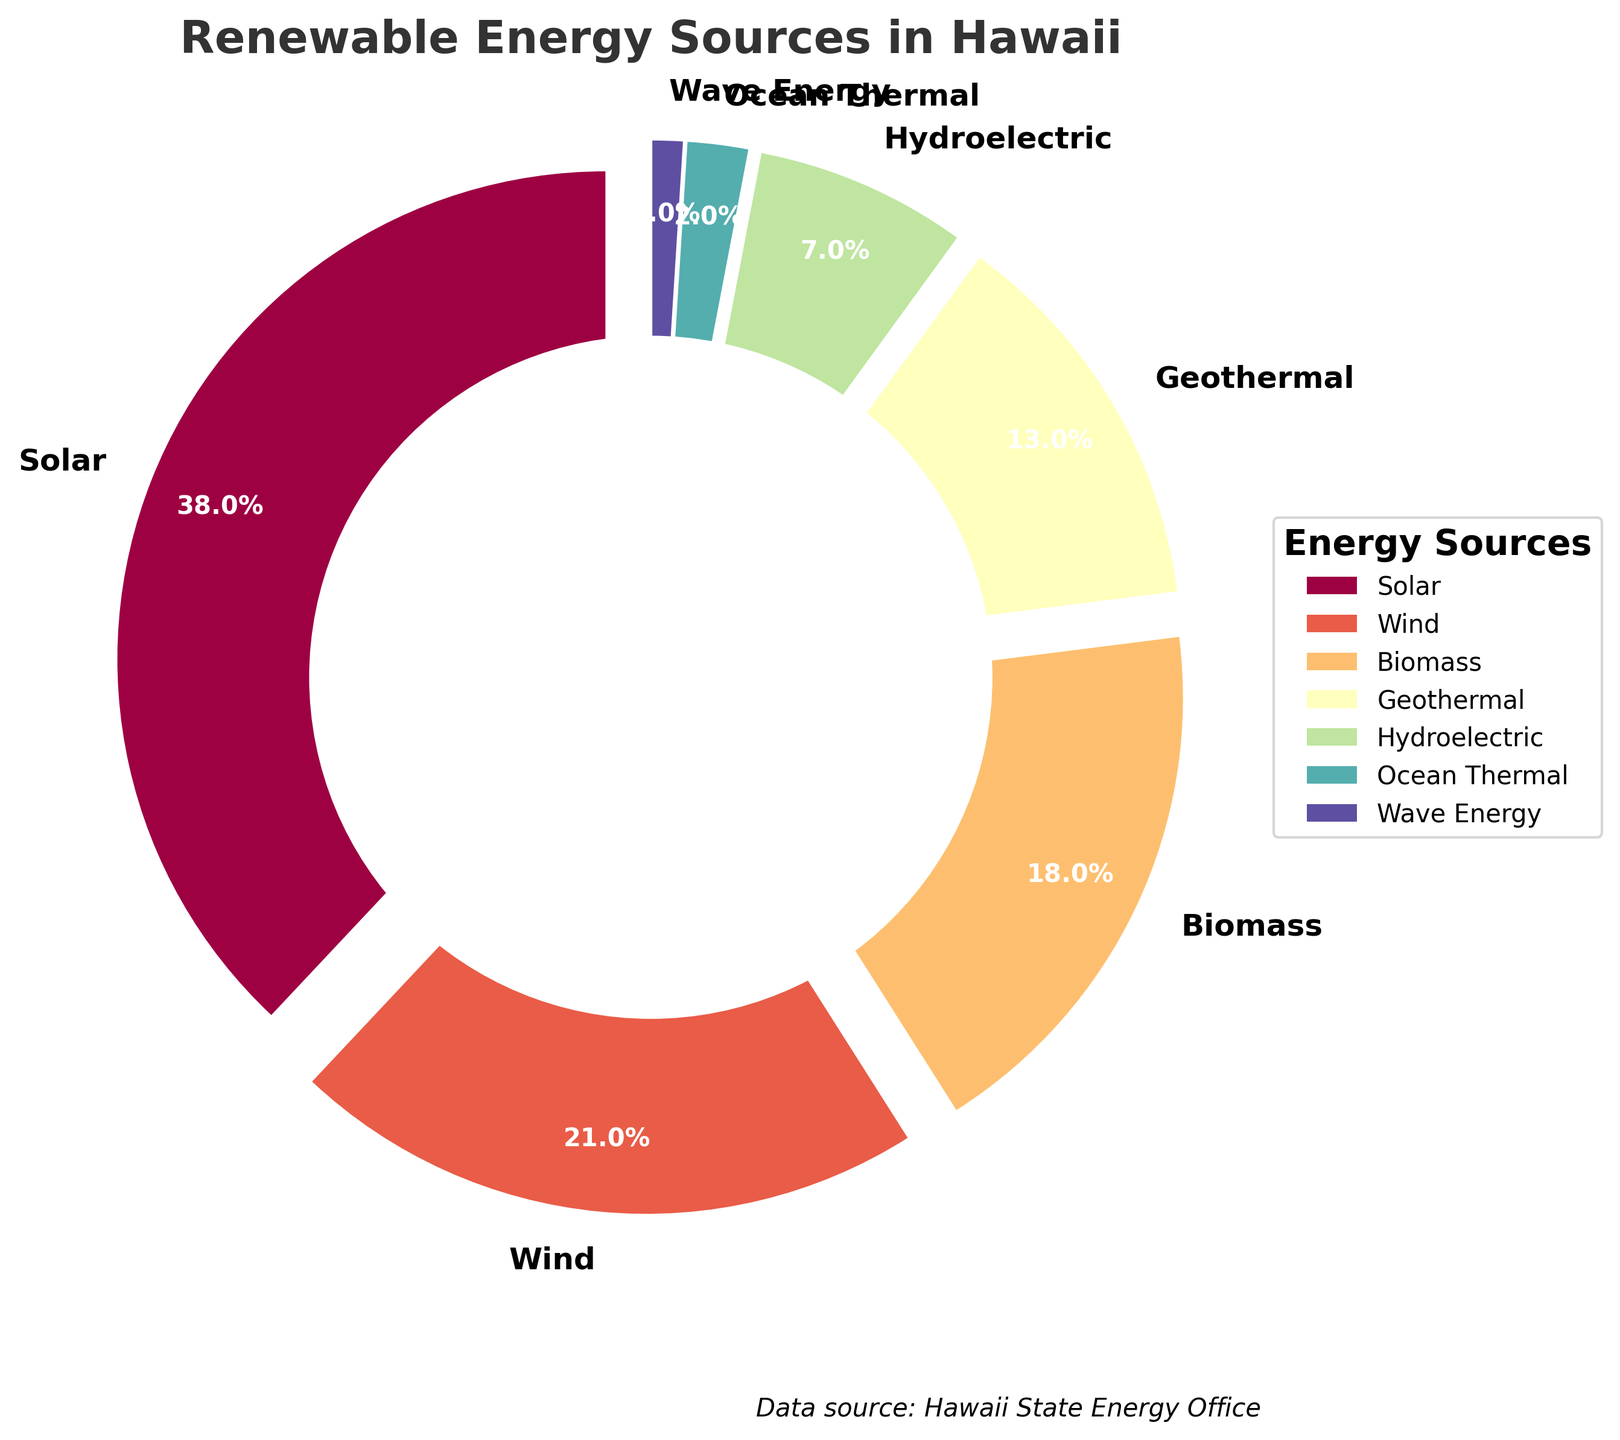What is the most common renewable energy source in Hawaii? The slice labeled with the highest percentage corresponds to the most common energy source. Here, Solar has the largest percentage of 38%.
Answer: Solar Which two sources combined represent over half of Hawaii's renewable energy? By adding the percentages of Solar and Wind (38% + 21%), we get 59%, which is more than half (50%).
Answer: Solar and Wind What is the percentage difference between Biomass and Geothermal energy sources? Subtract the percentage of Geothermal (13%) from the percentage of Biomass (18%) to find the difference. 18% - 13% = 5%.
Answer: 5% Which renewable energy source contributes the least, and what is its percentage? The smallest visible slice on the pie chart, with the lowest percentage, corresponds to Wave Energy. Its percentage is 1%.
Answer: Wave Energy, 1% Is the combined percentage of Hydroelectric and Ocean Thermal energy sources greater or less than that of Wind energy? Adding the percentages of Hydroelectric (7%) and Ocean Thermal (2%) gives us 9%. Since Wind accounts for 21%, 9% is less than 21%.
Answer: Less What is the average contribution of the three least common renewable energy sources? Adding the percentages of Ocean Thermal (2%), Wave Energy (1%), and Hydroelectric (7%) gives us 10%. The average is 10% divided by 3, which is approximately 3.33%.
Answer: ~3.33% How much more popular is Solar energy compared to Geothermal energy? Subtract the percentage of Geothermal (13%) from Solar (38%), which results in 38% - 13% = 25%. Therefore, Solar is 25% more popular.
Answer: 25% What fraction of the pie chart is Wind energy? Wind accounts for 21%, which can be represented as the fraction 21/100, or simplified, 21%.
Answer: 21% 